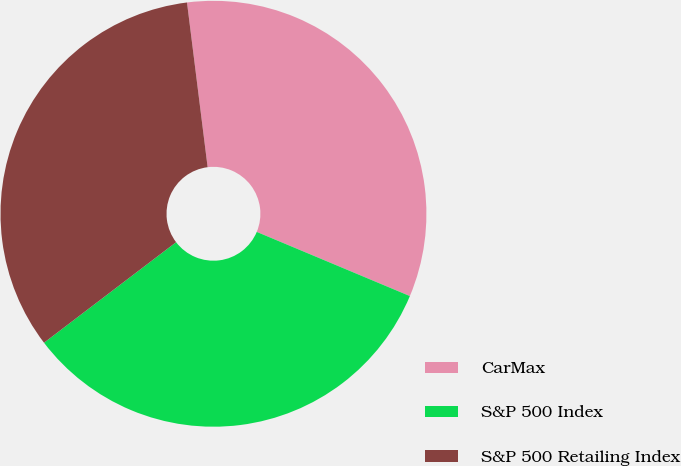Convert chart to OTSL. <chart><loc_0><loc_0><loc_500><loc_500><pie_chart><fcel>CarMax<fcel>S&P 500 Index<fcel>S&P 500 Retailing Index<nl><fcel>33.3%<fcel>33.33%<fcel>33.37%<nl></chart> 